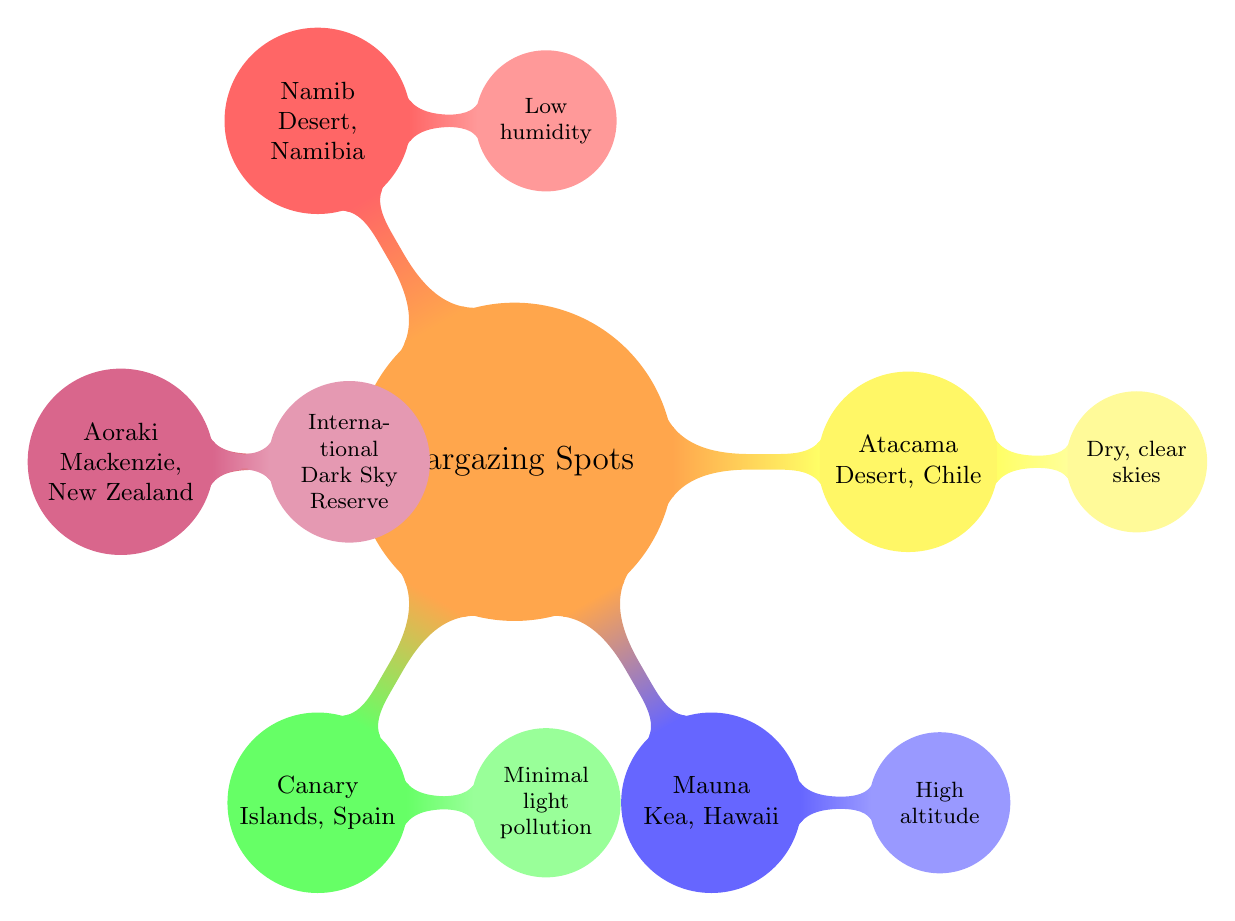What is the first stargazing spot listed in the diagram? The diagram starts with the main node "Stargazing Spots," from which the first child node branching out clockwise is "Atacama Desert, Chile."
Answer: Atacama Desert, Chile How many stargazing spots are featured in the diagram? The diagram displays a total of five child nodes emanating from the main node, each representing a stargazing spot.
Answer: 5 Which stargazing spot is associated with minimal light pollution? The diagram indicates that "Canary Islands, Spain" is the only spot explicitly stated to have "Minimal light pollution" as its description.
Answer: Canary Islands, Spain What characteristic is shared by both Atacama Desert and Namib Desert? The descriptions for "Atacama Desert, Chile" state "Dry, clear skies" and for "Namib Desert, Namibia," it mentions "Low humidity." Both spots are characterized by conditions that contribute to less weather interference during stargazing.
Answer: Dry Where can you find an International Dark Sky Reserve according to the diagram? The node for "Aoraki Mackenzie, New Zealand" states that it is designated as an "International Dark Sky Reserve," indicating a place dedicated to preserving the dark night skies.
Answer: Aoraki Mackenzie, New Zealand Which stargazing spot is located at a high altitude? "Mauna Kea, Hawaii" is specifically tied to the description of "High altitude," indicating it is situated at a notable elevation that enhances stargazing outcomes.
Answer: Mauna Kea, Hawaii What color represents the Canary Islands in the diagram? Each stargazing spot is highlighted in different colors, and "Canary Islands, Spain" is labeled with a green color.
Answer: Green Which two spots have weather conditions that make them most favorable for stargazing? "Atacama Desert, Chile" (dry clear skies) and "Namib Desert, Namibia" (low humidity) are both characterized by weather conditions that reduce atmospheric interference when stargazing, making them favorable locations.
Answer: Atacama Desert, Namibia How does the diagram categorize stargazing spots? The diagram categorizes stargazing spots using color-coded nodes, forming a mindmap structure that visually arranges each spot with its defining characteristics.
Answer: Color-coded nodes 